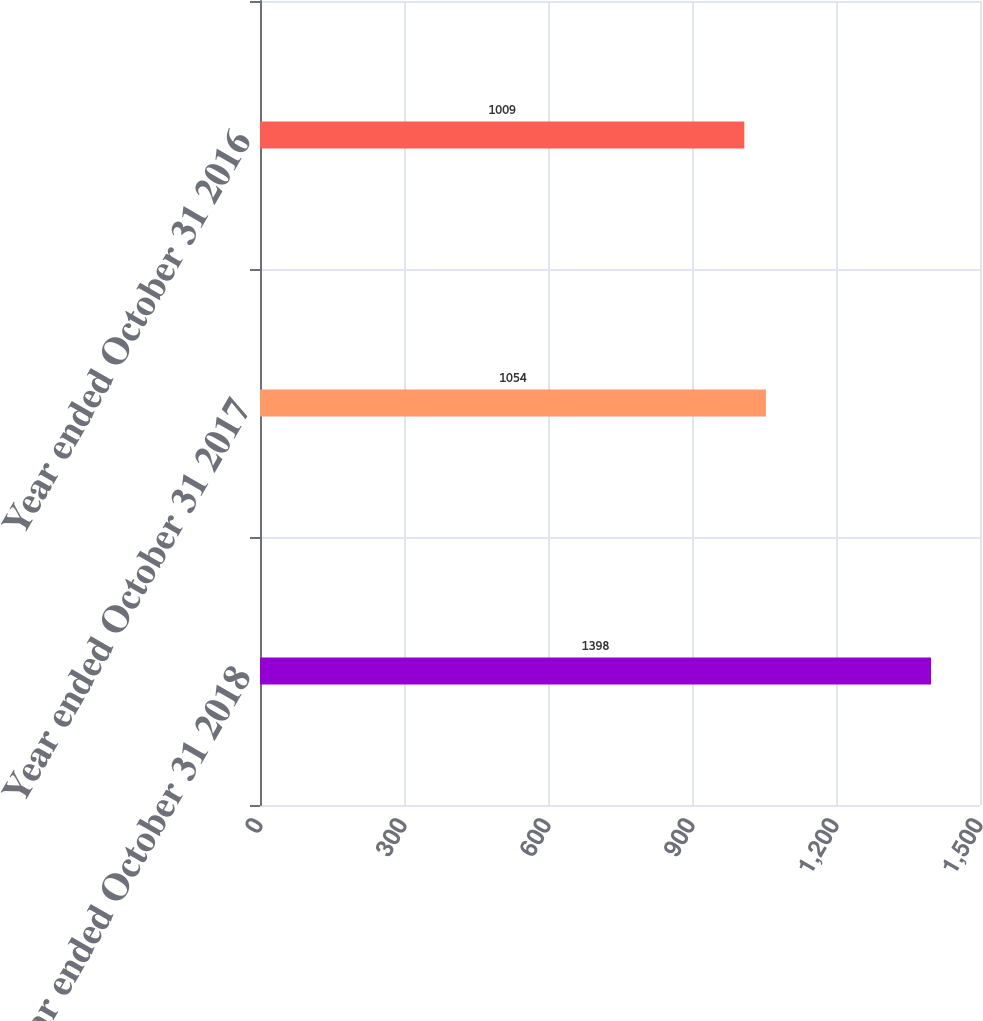Convert chart to OTSL. <chart><loc_0><loc_0><loc_500><loc_500><bar_chart><fcel>Year ended October 31 2018<fcel>Year ended October 31 2017<fcel>Year ended October 31 2016<nl><fcel>1398<fcel>1054<fcel>1009<nl></chart> 